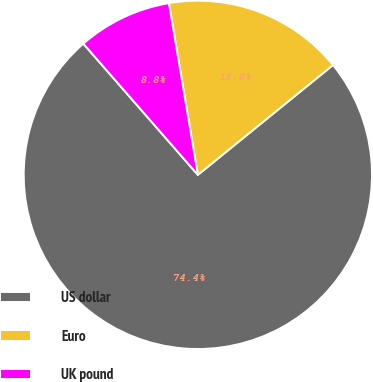Convert chart. <chart><loc_0><loc_0><loc_500><loc_500><pie_chart><fcel>US dollar<fcel>Euro<fcel>UK pound<nl><fcel>74.44%<fcel>16.8%<fcel>8.76%<nl></chart> 